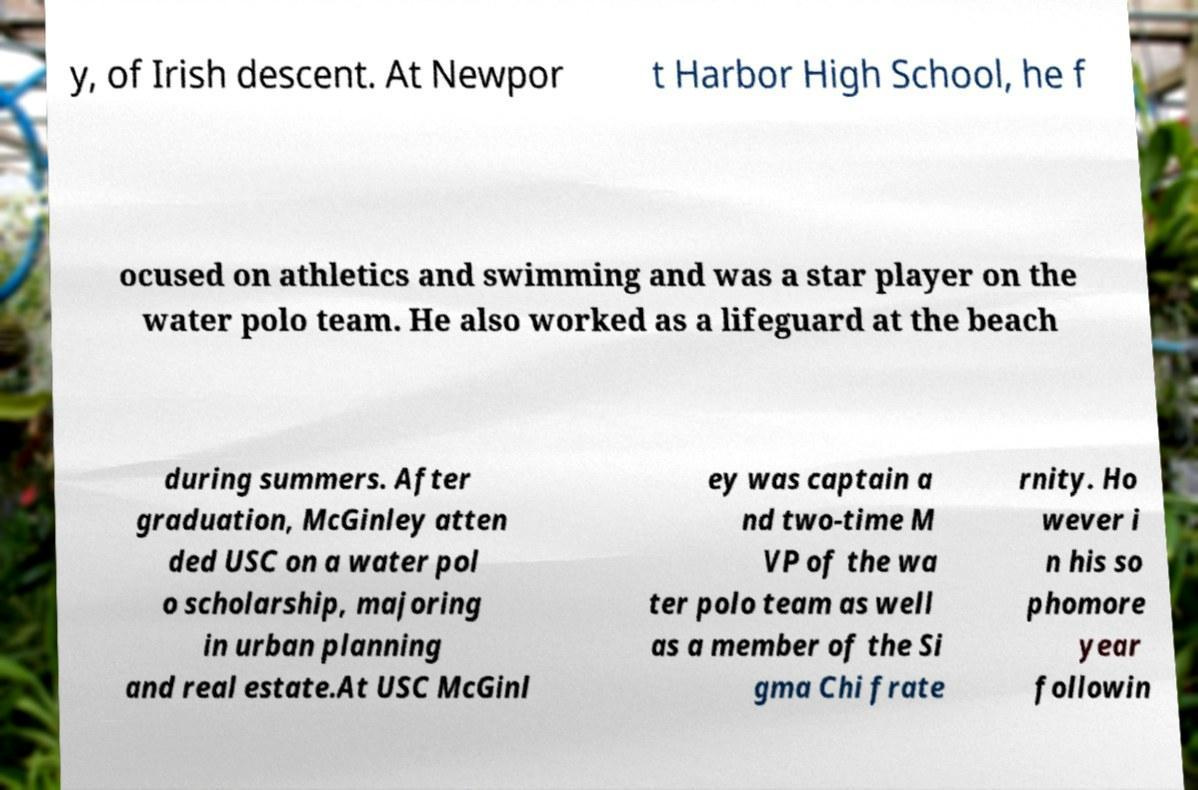Please read and relay the text visible in this image. What does it say? y, of Irish descent. At Newpor t Harbor High School, he f ocused on athletics and swimming and was a star player on the water polo team. He also worked as a lifeguard at the beach during summers. After graduation, McGinley atten ded USC on a water pol o scholarship, majoring in urban planning and real estate.At USC McGinl ey was captain a nd two-time M VP of the wa ter polo team as well as a member of the Si gma Chi frate rnity. Ho wever i n his so phomore year followin 